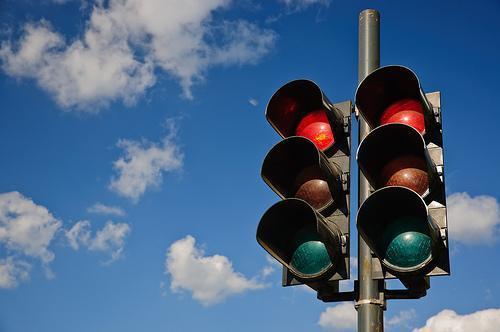How many poles are there?
Give a very brief answer. 1. 